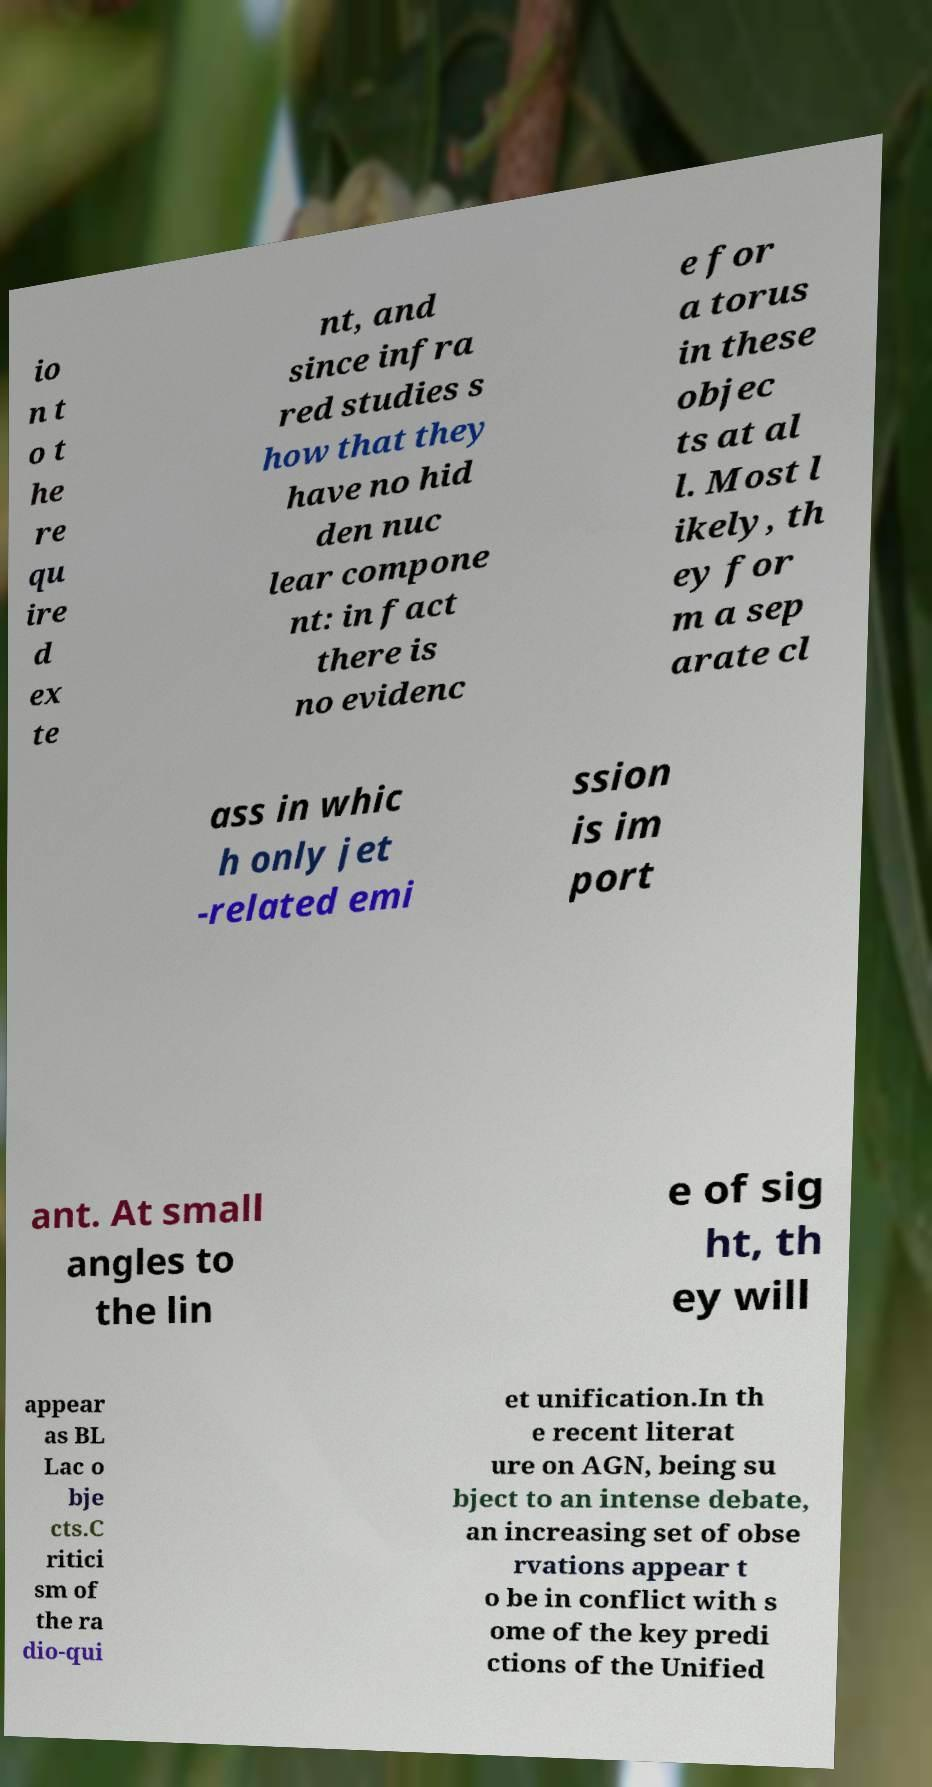I need the written content from this picture converted into text. Can you do that? io n t o t he re qu ire d ex te nt, and since infra red studies s how that they have no hid den nuc lear compone nt: in fact there is no evidenc e for a torus in these objec ts at al l. Most l ikely, th ey for m a sep arate cl ass in whic h only jet -related emi ssion is im port ant. At small angles to the lin e of sig ht, th ey will appear as BL Lac o bje cts.C ritici sm of the ra dio-qui et unification.In th e recent literat ure on AGN, being su bject to an intense debate, an increasing set of obse rvations appear t o be in conflict with s ome of the key predi ctions of the Unified 